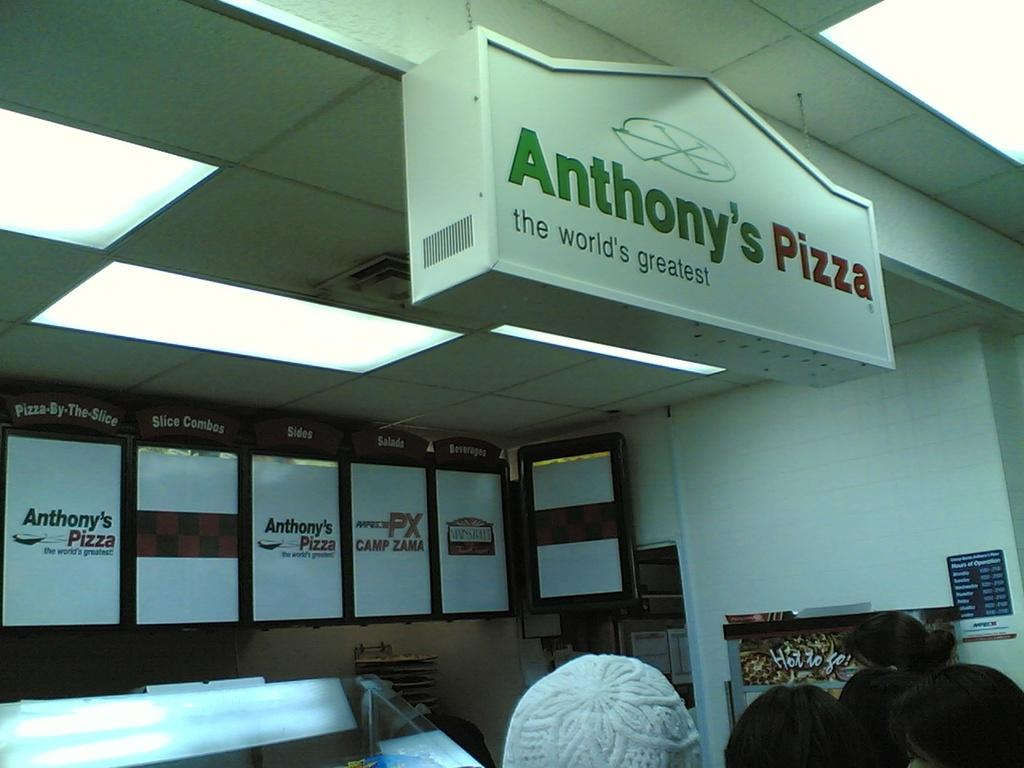What is located in the foreground of the image? There are heads of persons in the foreground of the image. What can be seen in the background of the image? There is a wall and boards in the background of the image. Are there any lighting fixtures visible in the image? Yes, there are lights attached to the ceiling in the background of the image. What type of vacation destination is depicted in the image? There is no indication of a vacation destination in the image; it features heads of persons, a wall, boards, and lights attached to the ceiling. Can you tell me how the wind is affecting the persons in the image? There is no mention of wind in the image, and therefore no such effect can be observed. 